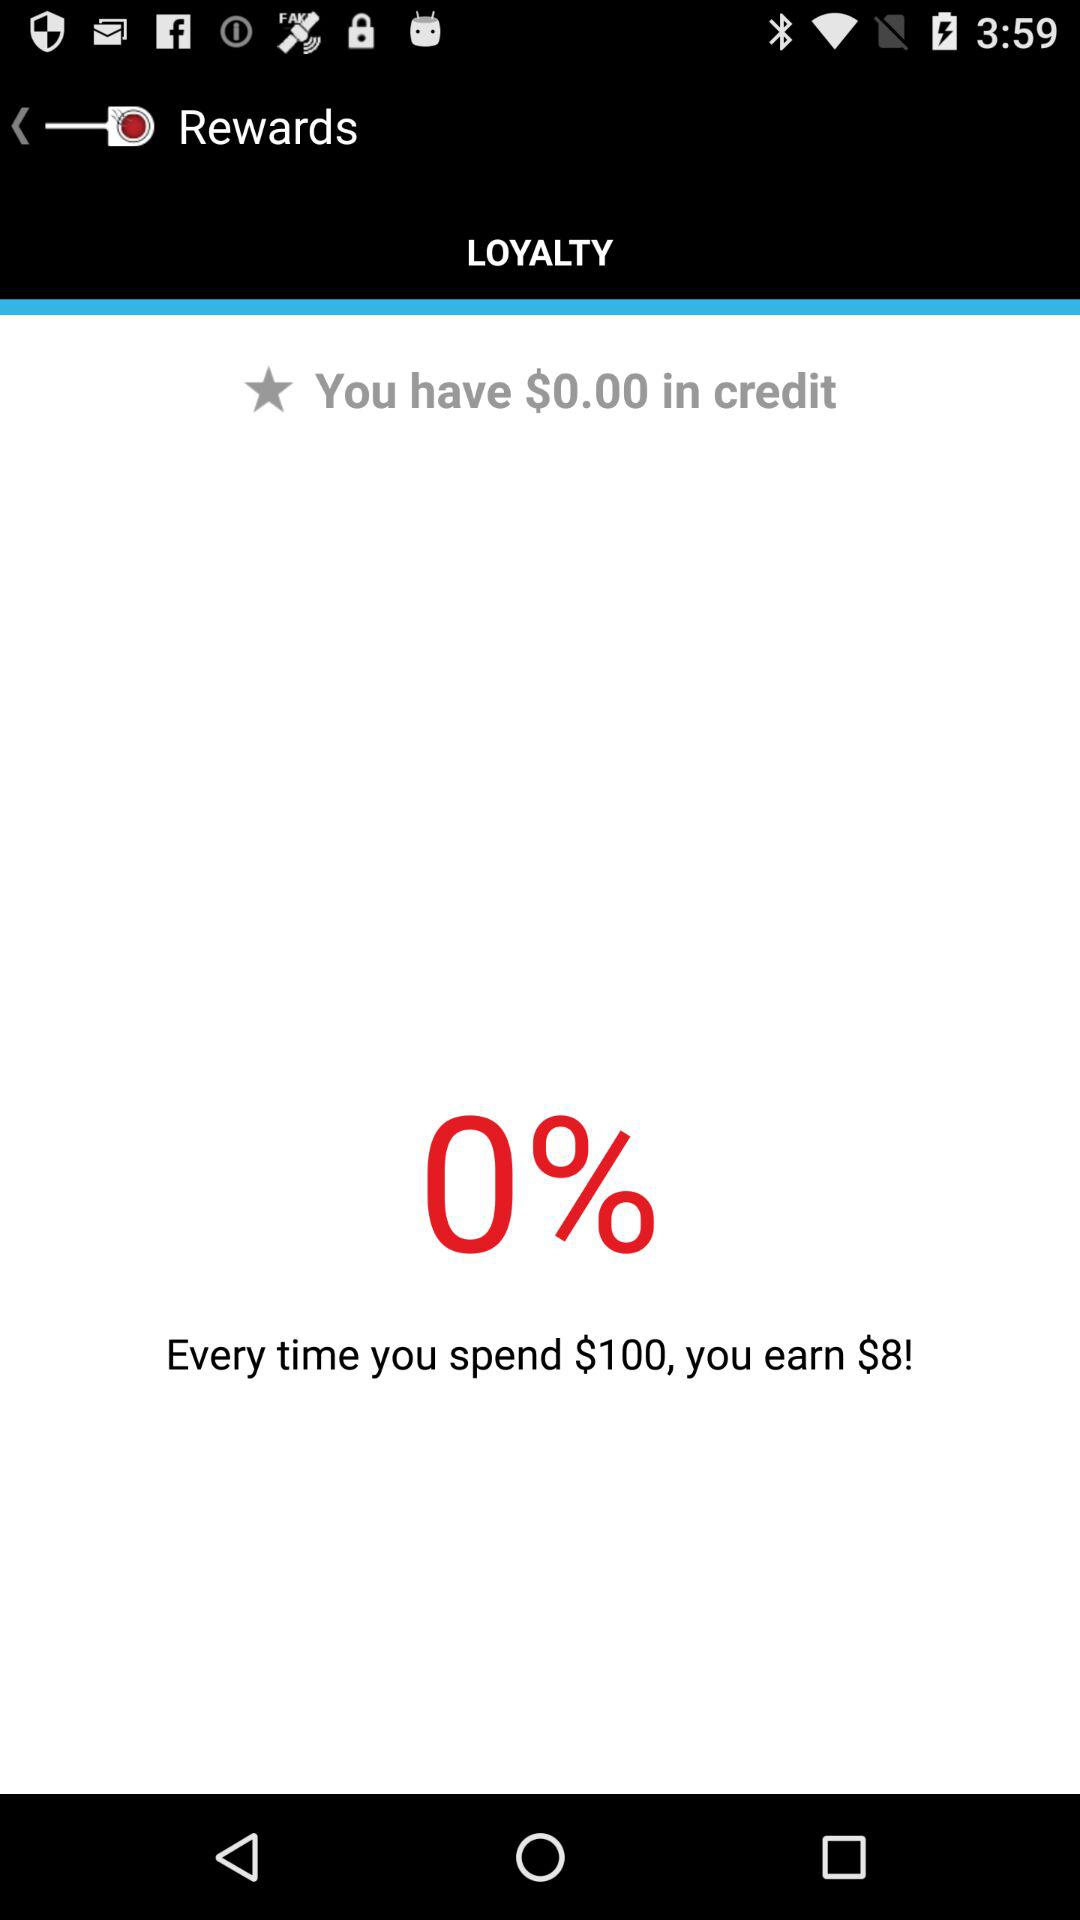What amount is in your account? The amount is $0.00. 